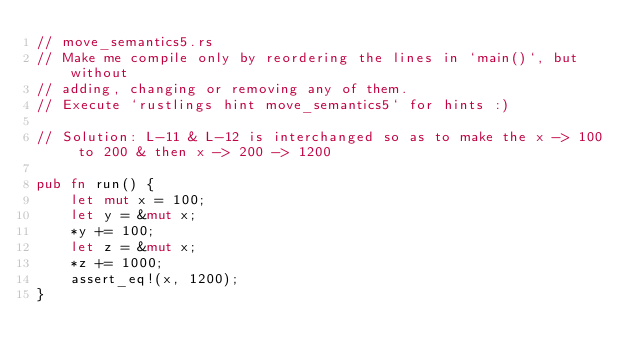<code> <loc_0><loc_0><loc_500><loc_500><_Rust_>// move_semantics5.rs
// Make me compile only by reordering the lines in `main()`, but without
// adding, changing or removing any of them.
// Execute `rustlings hint move_semantics5` for hints :)

// Solution: L-11 & L-12 is interchanged so as to make the x -> 100 to 200 & then x -> 200 -> 1200

pub fn run() {
    let mut x = 100;
    let y = &mut x;
    *y += 100;
    let z = &mut x;
    *z += 1000;
    assert_eq!(x, 1200);
}
</code> 